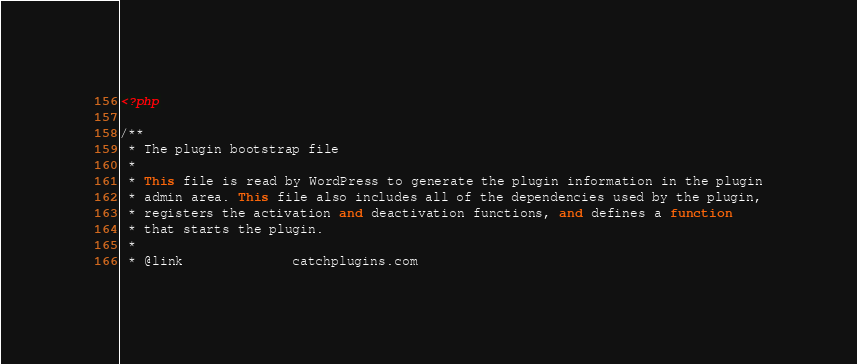Convert code to text. <code><loc_0><loc_0><loc_500><loc_500><_PHP_><?php

/**
 * The plugin bootstrap file
 *
 * This file is read by WordPress to generate the plugin information in the plugin
 * admin area. This file also includes all of the dependencies used by the plugin,
 * registers the activation and deactivation functions, and defines a function
 * that starts the plugin.
 *
 * @link              catchplugins.com</code> 